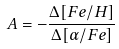Convert formula to latex. <formula><loc_0><loc_0><loc_500><loc_500>A = - \frac { \Delta [ F e / H ] } { \Delta [ \alpha / F e ] }</formula> 